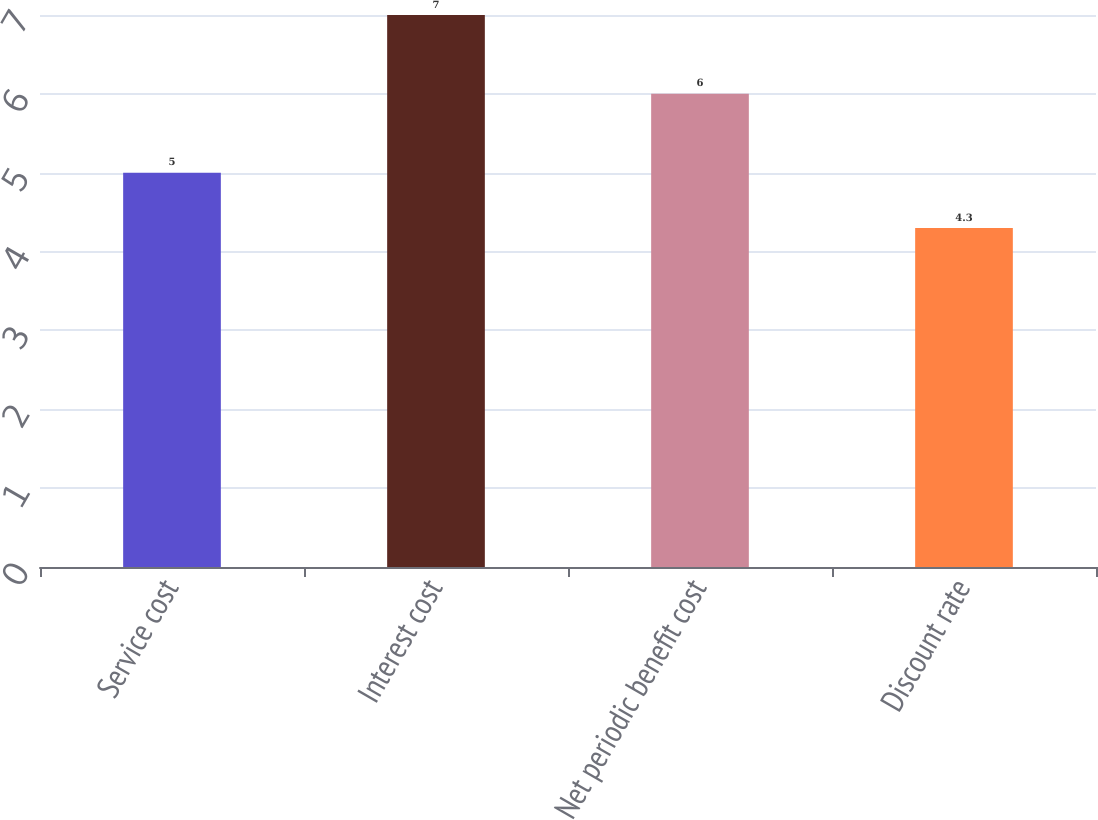Convert chart. <chart><loc_0><loc_0><loc_500><loc_500><bar_chart><fcel>Service cost<fcel>Interest cost<fcel>Net periodic benefit cost<fcel>Discount rate<nl><fcel>5<fcel>7<fcel>6<fcel>4.3<nl></chart> 